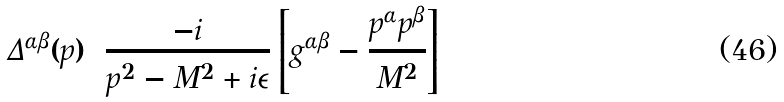<formula> <loc_0><loc_0><loc_500><loc_500>\Delta ^ { \alpha \beta } ( p ) = \frac { - i } { p ^ { 2 } - M ^ { 2 } + i \epsilon } \left [ g ^ { \alpha \beta } - \frac { p ^ { \alpha } p ^ { \beta } } { M ^ { 2 } } \right ]</formula> 